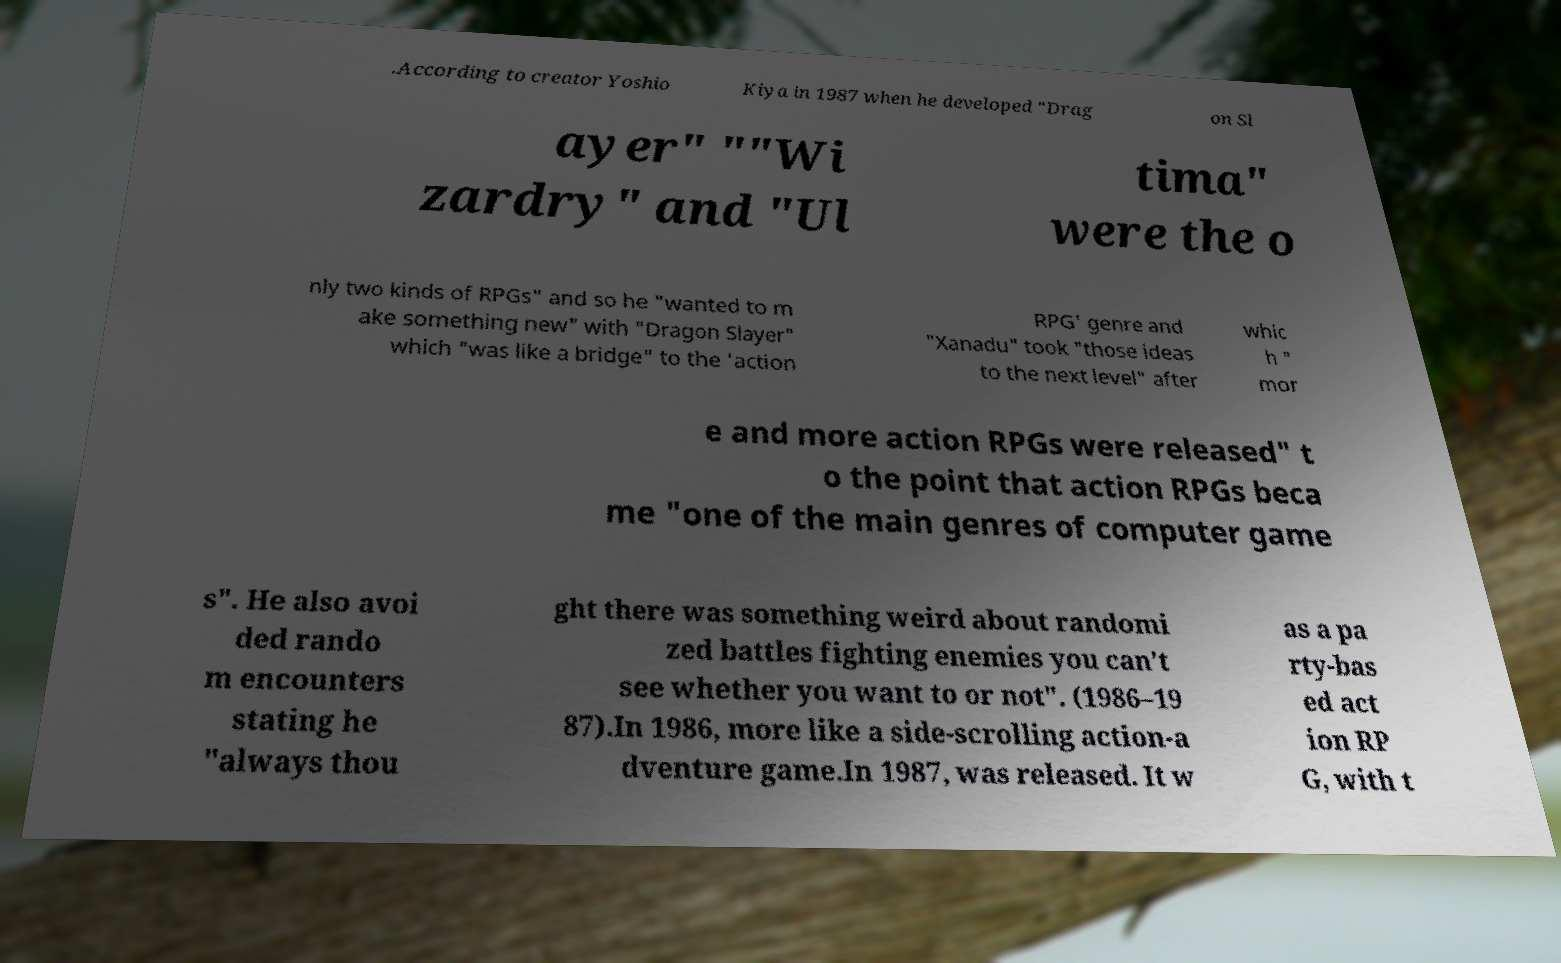Can you accurately transcribe the text from the provided image for me? .According to creator Yoshio Kiya in 1987 when he developed "Drag on Sl ayer" ""Wi zardry" and "Ul tima" were the o nly two kinds of RPGs" and so he "wanted to m ake something new" with "Dragon Slayer" which "was like a bridge" to the 'action RPG' genre and "Xanadu" took "those ideas to the next level" after whic h " mor e and more action RPGs were released" t o the point that action RPGs beca me "one of the main genres of computer game s". He also avoi ded rando m encounters stating he "always thou ght there was something weird about randomi zed battles fighting enemies you can’t see whether you want to or not". (1986–19 87).In 1986, more like a side-scrolling action-a dventure game.In 1987, was released. It w as a pa rty-bas ed act ion RP G, with t 